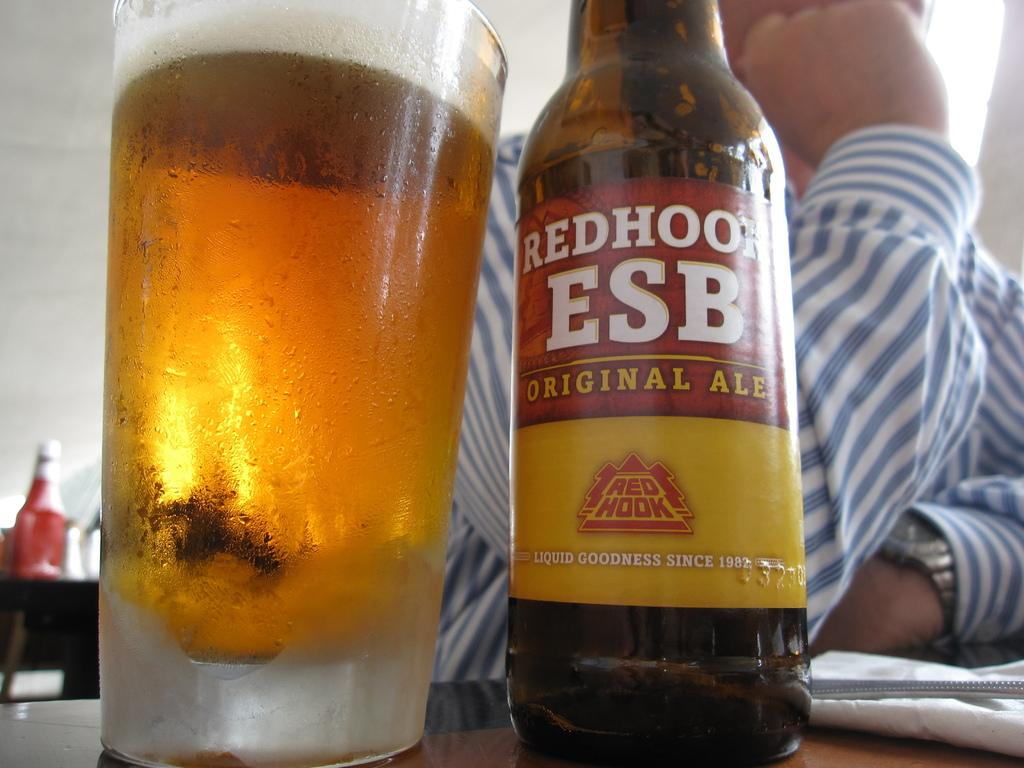What type of beverage is present on the table in the image? There is a bottle of beer on the table. What accompanies the bottle of beer on the table? There is a glass of beer beside the bottle. Can you describe the person in the image? There is a person behind the bottle, but their appearance or actions are not specified. What type of lunch is being served on the coast in the image? There is no mention of lunch or a coast in the image; it only features a bottle of beer and a glass of beer on a table. 